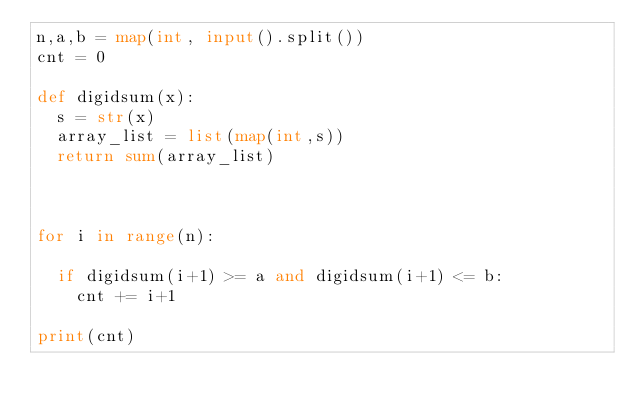Convert code to text. <code><loc_0><loc_0><loc_500><loc_500><_Python_>n,a,b = map(int, input().split())
cnt = 0

def digidsum(x):
  s = str(x)
  array_list = list(map(int,s))
  return sum(array_list)



for i in range(n):

  if digidsum(i+1) >= a and digidsum(i+1) <= b:
    cnt += i+1
    
print(cnt)</code> 